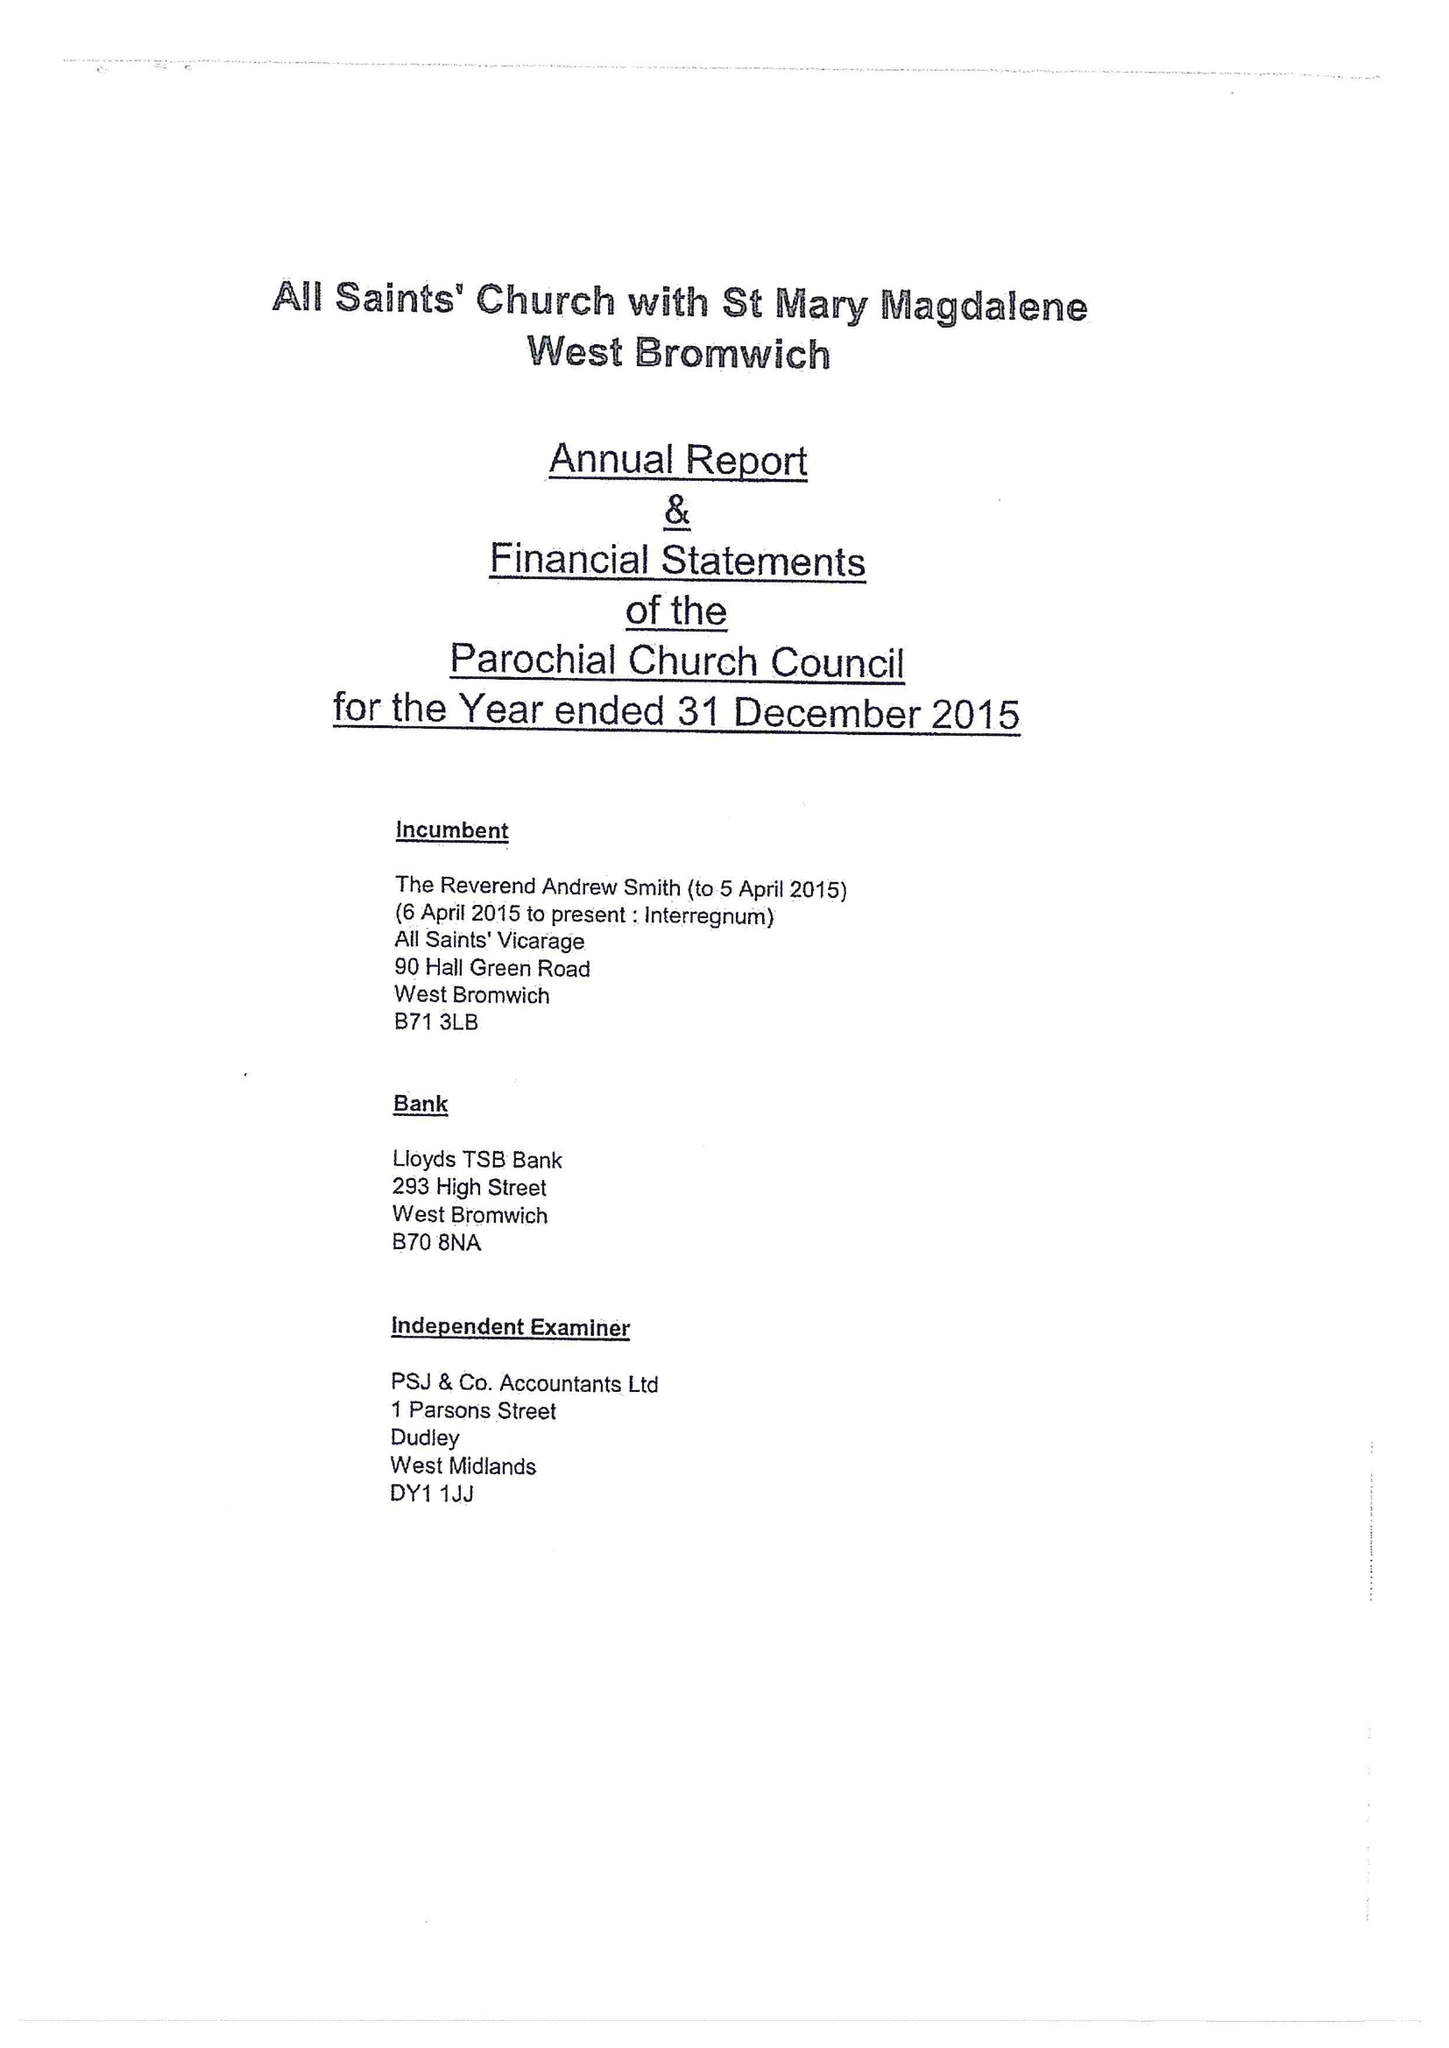What is the value for the charity_name?
Answer the question using a single word or phrase. The Parochial Church Council Of The Ecclesiastical Parish Of West Bromwich 